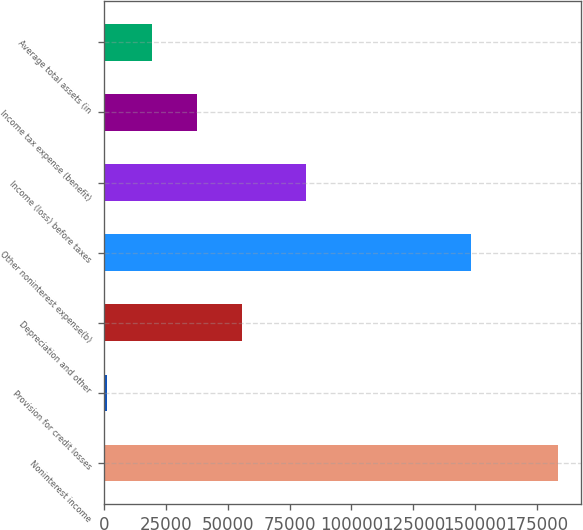Convert chart to OTSL. <chart><loc_0><loc_0><loc_500><loc_500><bar_chart><fcel>Noninterest income<fcel>Provision for credit losses<fcel>Depreciation and other<fcel>Other noninterest expense(b)<fcel>Income (loss) before taxes<fcel>Income tax expense (benefit)<fcel>Average total assets (in<nl><fcel>183677<fcel>953<fcel>55770.2<fcel>148432<fcel>81787<fcel>37497.8<fcel>19225.4<nl></chart> 